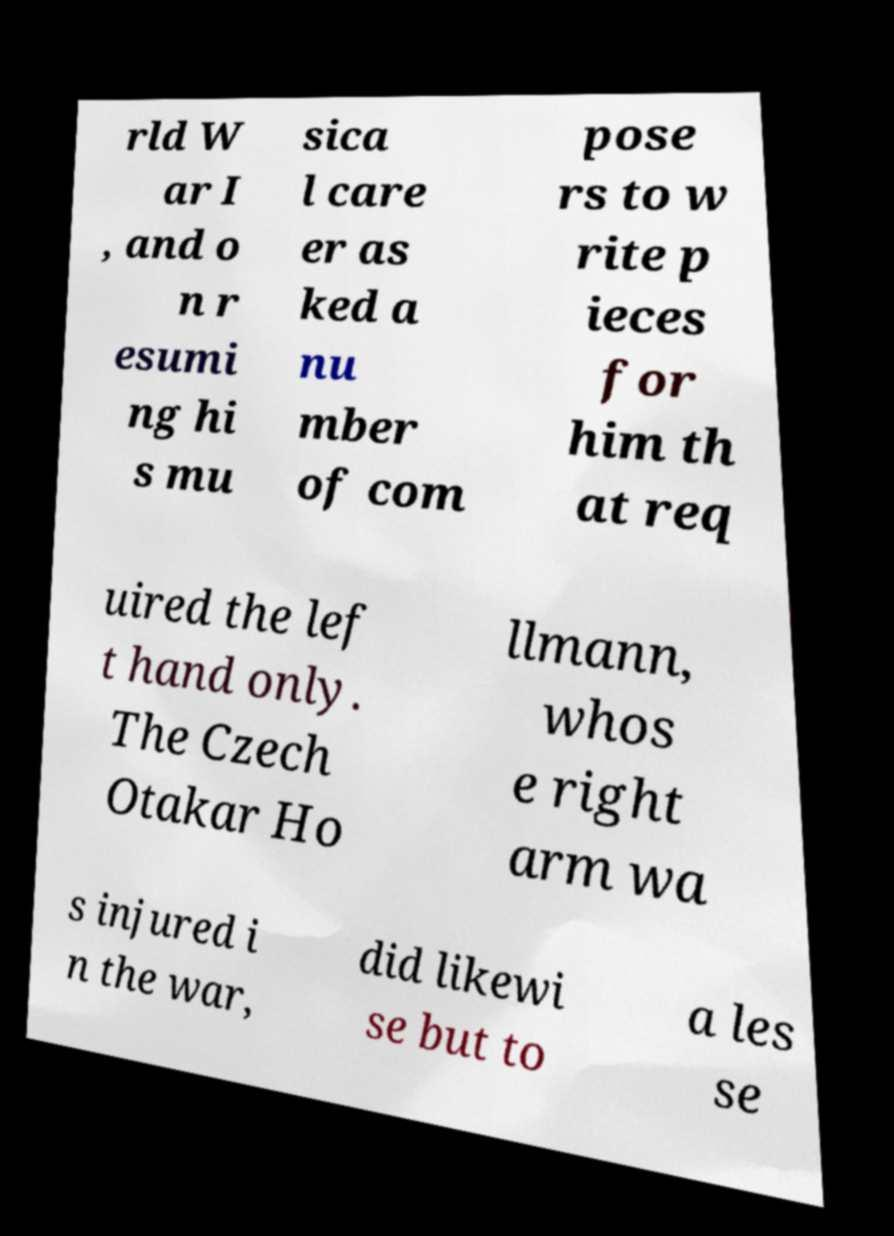Please identify and transcribe the text found in this image. rld W ar I , and o n r esumi ng hi s mu sica l care er as ked a nu mber of com pose rs to w rite p ieces for him th at req uired the lef t hand only. The Czech Otakar Ho llmann, whos e right arm wa s injured i n the war, did likewi se but to a les se 